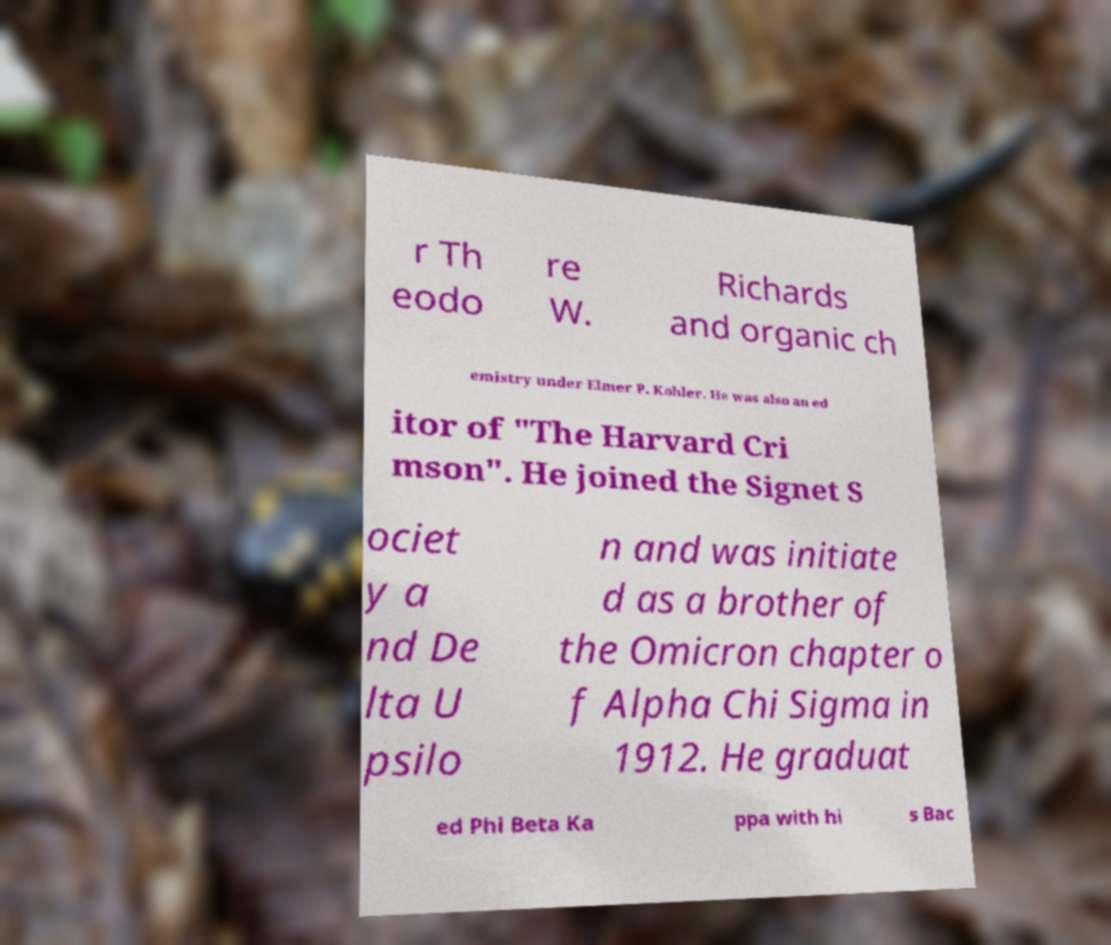There's text embedded in this image that I need extracted. Can you transcribe it verbatim? r Th eodo re W. Richards and organic ch emistry under Elmer P. Kohler. He was also an ed itor of "The Harvard Cri mson". He joined the Signet S ociet y a nd De lta U psilo n and was initiate d as a brother of the Omicron chapter o f Alpha Chi Sigma in 1912. He graduat ed Phi Beta Ka ppa with hi s Bac 